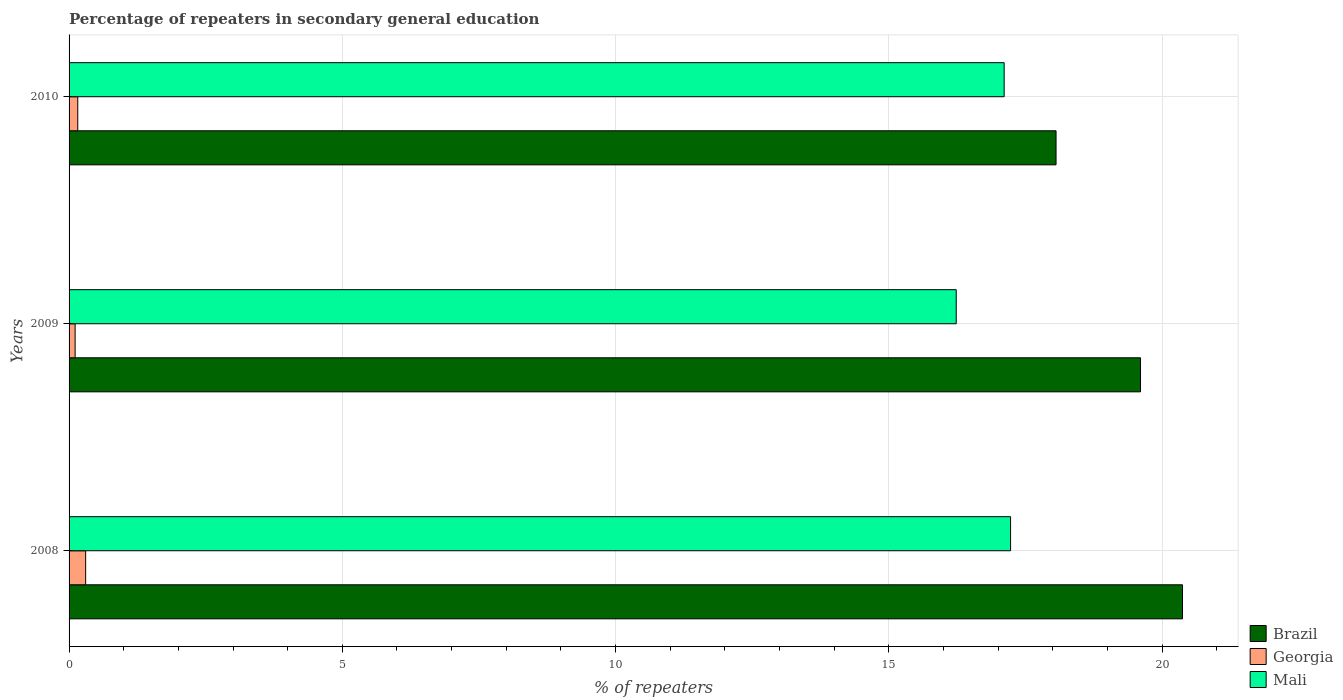How many different coloured bars are there?
Provide a short and direct response. 3. How many groups of bars are there?
Keep it short and to the point. 3. Are the number of bars on each tick of the Y-axis equal?
Ensure brevity in your answer.  Yes. How many bars are there on the 2nd tick from the top?
Provide a succinct answer. 3. What is the percentage of repeaters in secondary general education in Georgia in 2008?
Offer a very short reply. 0.3. Across all years, what is the maximum percentage of repeaters in secondary general education in Georgia?
Ensure brevity in your answer.  0.3. Across all years, what is the minimum percentage of repeaters in secondary general education in Brazil?
Ensure brevity in your answer.  18.06. In which year was the percentage of repeaters in secondary general education in Georgia maximum?
Your answer should be compact. 2008. In which year was the percentage of repeaters in secondary general education in Mali minimum?
Ensure brevity in your answer.  2009. What is the total percentage of repeaters in secondary general education in Mali in the graph?
Provide a succinct answer. 50.57. What is the difference between the percentage of repeaters in secondary general education in Mali in 2009 and that in 2010?
Provide a short and direct response. -0.88. What is the difference between the percentage of repeaters in secondary general education in Brazil in 2010 and the percentage of repeaters in secondary general education in Mali in 2009?
Keep it short and to the point. 1.83. What is the average percentage of repeaters in secondary general education in Brazil per year?
Offer a terse response. 19.35. In the year 2009, what is the difference between the percentage of repeaters in secondary general education in Brazil and percentage of repeaters in secondary general education in Georgia?
Ensure brevity in your answer.  19.5. What is the ratio of the percentage of repeaters in secondary general education in Mali in 2008 to that in 2010?
Provide a succinct answer. 1.01. Is the difference between the percentage of repeaters in secondary general education in Brazil in 2008 and 2009 greater than the difference between the percentage of repeaters in secondary general education in Georgia in 2008 and 2009?
Your answer should be very brief. Yes. What is the difference between the highest and the second highest percentage of repeaters in secondary general education in Mali?
Give a very brief answer. 0.12. What is the difference between the highest and the lowest percentage of repeaters in secondary general education in Georgia?
Your answer should be very brief. 0.19. Is it the case that in every year, the sum of the percentage of repeaters in secondary general education in Mali and percentage of repeaters in secondary general education in Brazil is greater than the percentage of repeaters in secondary general education in Georgia?
Make the answer very short. Yes. How many bars are there?
Provide a short and direct response. 9. Are all the bars in the graph horizontal?
Make the answer very short. Yes. How many years are there in the graph?
Your answer should be very brief. 3. Are the values on the major ticks of X-axis written in scientific E-notation?
Ensure brevity in your answer.  No. Does the graph contain grids?
Give a very brief answer. Yes. Where does the legend appear in the graph?
Your answer should be compact. Bottom right. How many legend labels are there?
Your answer should be compact. 3. How are the legend labels stacked?
Your answer should be compact. Vertical. What is the title of the graph?
Provide a short and direct response. Percentage of repeaters in secondary general education. Does "Other small states" appear as one of the legend labels in the graph?
Ensure brevity in your answer.  No. What is the label or title of the X-axis?
Ensure brevity in your answer.  % of repeaters. What is the % of repeaters of Brazil in 2008?
Provide a succinct answer. 20.37. What is the % of repeaters in Georgia in 2008?
Offer a very short reply. 0.3. What is the % of repeaters in Mali in 2008?
Offer a terse response. 17.23. What is the % of repeaters of Brazil in 2009?
Offer a terse response. 19.61. What is the % of repeaters of Georgia in 2009?
Ensure brevity in your answer.  0.11. What is the % of repeaters in Mali in 2009?
Your answer should be very brief. 16.23. What is the % of repeaters in Brazil in 2010?
Offer a terse response. 18.06. What is the % of repeaters of Georgia in 2010?
Give a very brief answer. 0.16. What is the % of repeaters of Mali in 2010?
Give a very brief answer. 17.11. Across all years, what is the maximum % of repeaters in Brazil?
Offer a terse response. 20.37. Across all years, what is the maximum % of repeaters of Georgia?
Provide a succinct answer. 0.3. Across all years, what is the maximum % of repeaters in Mali?
Keep it short and to the point. 17.23. Across all years, what is the minimum % of repeaters in Brazil?
Your response must be concise. 18.06. Across all years, what is the minimum % of repeaters of Georgia?
Your answer should be compact. 0.11. Across all years, what is the minimum % of repeaters of Mali?
Provide a short and direct response. 16.23. What is the total % of repeaters of Brazil in the graph?
Offer a very short reply. 58.04. What is the total % of repeaters in Georgia in the graph?
Your answer should be compact. 0.57. What is the total % of repeaters in Mali in the graph?
Provide a succinct answer. 50.57. What is the difference between the % of repeaters in Brazil in 2008 and that in 2009?
Make the answer very short. 0.77. What is the difference between the % of repeaters of Georgia in 2008 and that in 2009?
Your response must be concise. 0.19. What is the difference between the % of repeaters of Brazil in 2008 and that in 2010?
Offer a very short reply. 2.31. What is the difference between the % of repeaters of Georgia in 2008 and that in 2010?
Make the answer very short. 0.14. What is the difference between the % of repeaters of Mali in 2008 and that in 2010?
Ensure brevity in your answer.  0.12. What is the difference between the % of repeaters of Brazil in 2009 and that in 2010?
Provide a succinct answer. 1.55. What is the difference between the % of repeaters in Georgia in 2009 and that in 2010?
Make the answer very short. -0.05. What is the difference between the % of repeaters in Mali in 2009 and that in 2010?
Provide a succinct answer. -0.88. What is the difference between the % of repeaters of Brazil in 2008 and the % of repeaters of Georgia in 2009?
Offer a very short reply. 20.26. What is the difference between the % of repeaters in Brazil in 2008 and the % of repeaters in Mali in 2009?
Ensure brevity in your answer.  4.14. What is the difference between the % of repeaters of Georgia in 2008 and the % of repeaters of Mali in 2009?
Your answer should be compact. -15.93. What is the difference between the % of repeaters of Brazil in 2008 and the % of repeaters of Georgia in 2010?
Ensure brevity in your answer.  20.21. What is the difference between the % of repeaters of Brazil in 2008 and the % of repeaters of Mali in 2010?
Keep it short and to the point. 3.26. What is the difference between the % of repeaters of Georgia in 2008 and the % of repeaters of Mali in 2010?
Keep it short and to the point. -16.81. What is the difference between the % of repeaters of Brazil in 2009 and the % of repeaters of Georgia in 2010?
Your answer should be compact. 19.45. What is the difference between the % of repeaters in Brazil in 2009 and the % of repeaters in Mali in 2010?
Keep it short and to the point. 2.5. What is the difference between the % of repeaters in Georgia in 2009 and the % of repeaters in Mali in 2010?
Keep it short and to the point. -17. What is the average % of repeaters in Brazil per year?
Offer a very short reply. 19.35. What is the average % of repeaters in Georgia per year?
Give a very brief answer. 0.19. What is the average % of repeaters in Mali per year?
Provide a succinct answer. 16.86. In the year 2008, what is the difference between the % of repeaters in Brazil and % of repeaters in Georgia?
Give a very brief answer. 20.07. In the year 2008, what is the difference between the % of repeaters of Brazil and % of repeaters of Mali?
Give a very brief answer. 3.15. In the year 2008, what is the difference between the % of repeaters in Georgia and % of repeaters in Mali?
Make the answer very short. -16.92. In the year 2009, what is the difference between the % of repeaters of Brazil and % of repeaters of Georgia?
Make the answer very short. 19.5. In the year 2009, what is the difference between the % of repeaters of Brazil and % of repeaters of Mali?
Keep it short and to the point. 3.37. In the year 2009, what is the difference between the % of repeaters of Georgia and % of repeaters of Mali?
Your answer should be compact. -16.12. In the year 2010, what is the difference between the % of repeaters of Brazil and % of repeaters of Georgia?
Ensure brevity in your answer.  17.9. In the year 2010, what is the difference between the % of repeaters in Brazil and % of repeaters in Mali?
Keep it short and to the point. 0.95. In the year 2010, what is the difference between the % of repeaters of Georgia and % of repeaters of Mali?
Provide a succinct answer. -16.95. What is the ratio of the % of repeaters in Brazil in 2008 to that in 2009?
Your response must be concise. 1.04. What is the ratio of the % of repeaters of Georgia in 2008 to that in 2009?
Give a very brief answer. 2.74. What is the ratio of the % of repeaters of Mali in 2008 to that in 2009?
Provide a short and direct response. 1.06. What is the ratio of the % of repeaters of Brazil in 2008 to that in 2010?
Provide a succinct answer. 1.13. What is the ratio of the % of repeaters in Georgia in 2008 to that in 2010?
Make the answer very short. 1.91. What is the ratio of the % of repeaters in Brazil in 2009 to that in 2010?
Offer a very short reply. 1.09. What is the ratio of the % of repeaters in Georgia in 2009 to that in 2010?
Provide a succinct answer. 0.7. What is the ratio of the % of repeaters in Mali in 2009 to that in 2010?
Ensure brevity in your answer.  0.95. What is the difference between the highest and the second highest % of repeaters in Brazil?
Your response must be concise. 0.77. What is the difference between the highest and the second highest % of repeaters in Georgia?
Ensure brevity in your answer.  0.14. What is the difference between the highest and the second highest % of repeaters of Mali?
Your answer should be compact. 0.12. What is the difference between the highest and the lowest % of repeaters in Brazil?
Offer a very short reply. 2.31. What is the difference between the highest and the lowest % of repeaters in Georgia?
Make the answer very short. 0.19. What is the difference between the highest and the lowest % of repeaters of Mali?
Give a very brief answer. 0.99. 